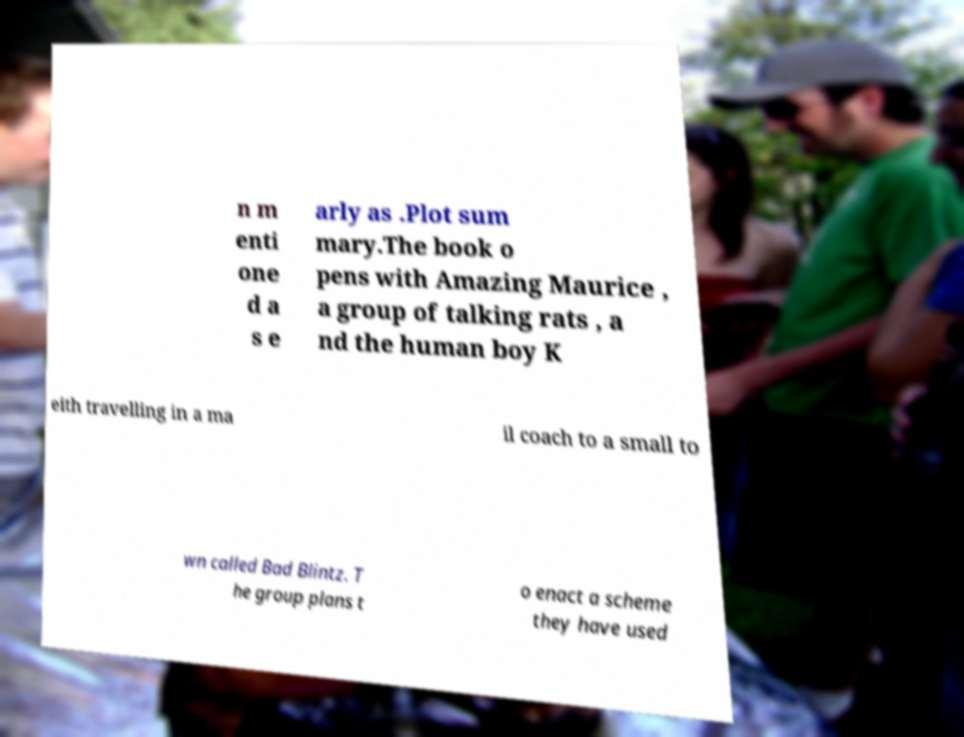Could you assist in decoding the text presented in this image and type it out clearly? n m enti one d a s e arly as .Plot sum mary.The book o pens with Amazing Maurice , a group of talking rats , a nd the human boy K eith travelling in a ma il coach to a small to wn called Bad Blintz. T he group plans t o enact a scheme they have used 